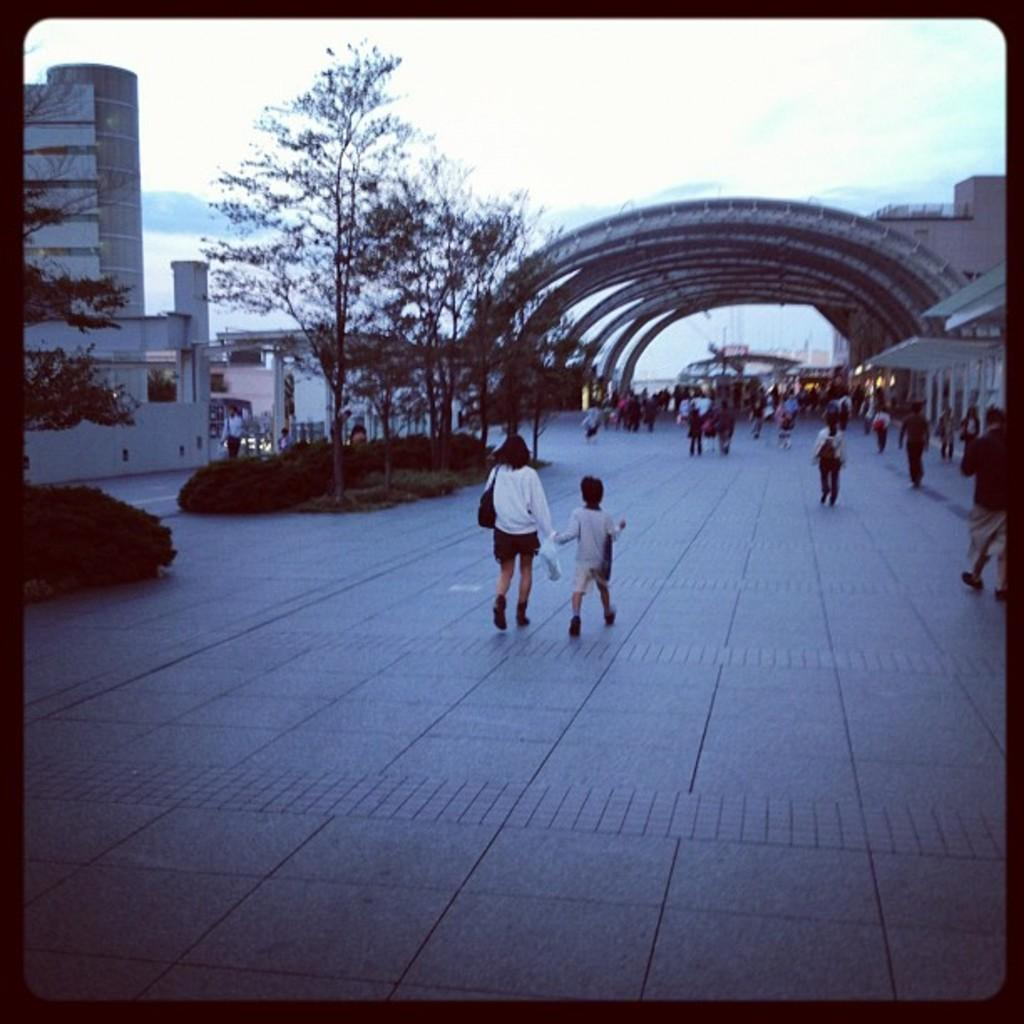What are the people in the image doing? There are groups of people walking in the image. What type of vegetation can be seen in the image? There are trees and bushes in the image. What type of structures are visible in the image? There are buildings in the image. What can be seen in the background of the image? The sky is visible in the background of the image. What riddle is being solved by the bird in the image? There is no bird present in the image, and therefore no riddle can be solved by a bird. What type of roof is visible on the buildings in the image? The provided facts do not mention the type of roof on the buildings, so it cannot be determined from the image. 